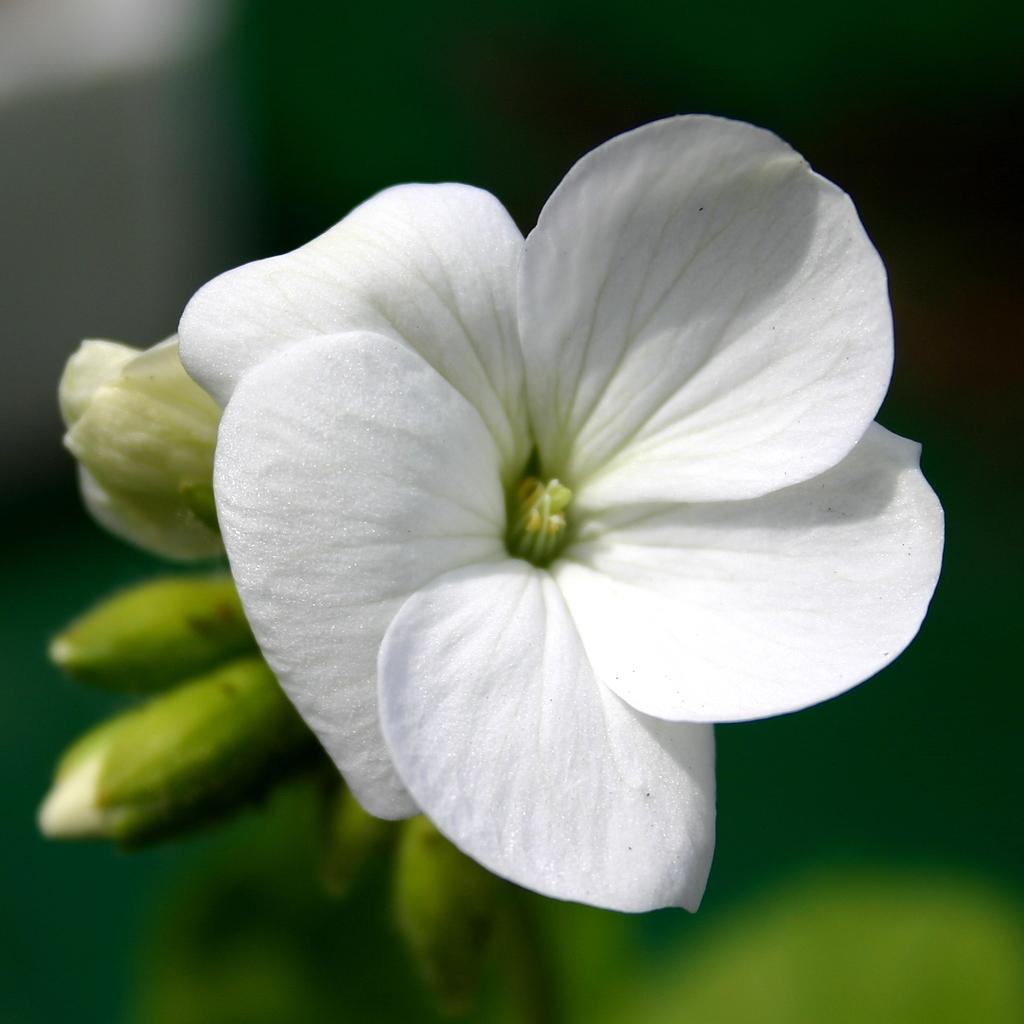What type of plants can be seen in the image? There are flowers in the image. Can you describe the stage of growth for some of the plants? Yes, there are buds in the image. What is the appearance of the background in the image? The background of the image is blurry. How many tents are visible in the image? There are no tents present in the image. What is the fifth element in the image? The facts provided do not mention a fifth element, and there are only three elements mentioned: flowers, buds, and a blurry background. 